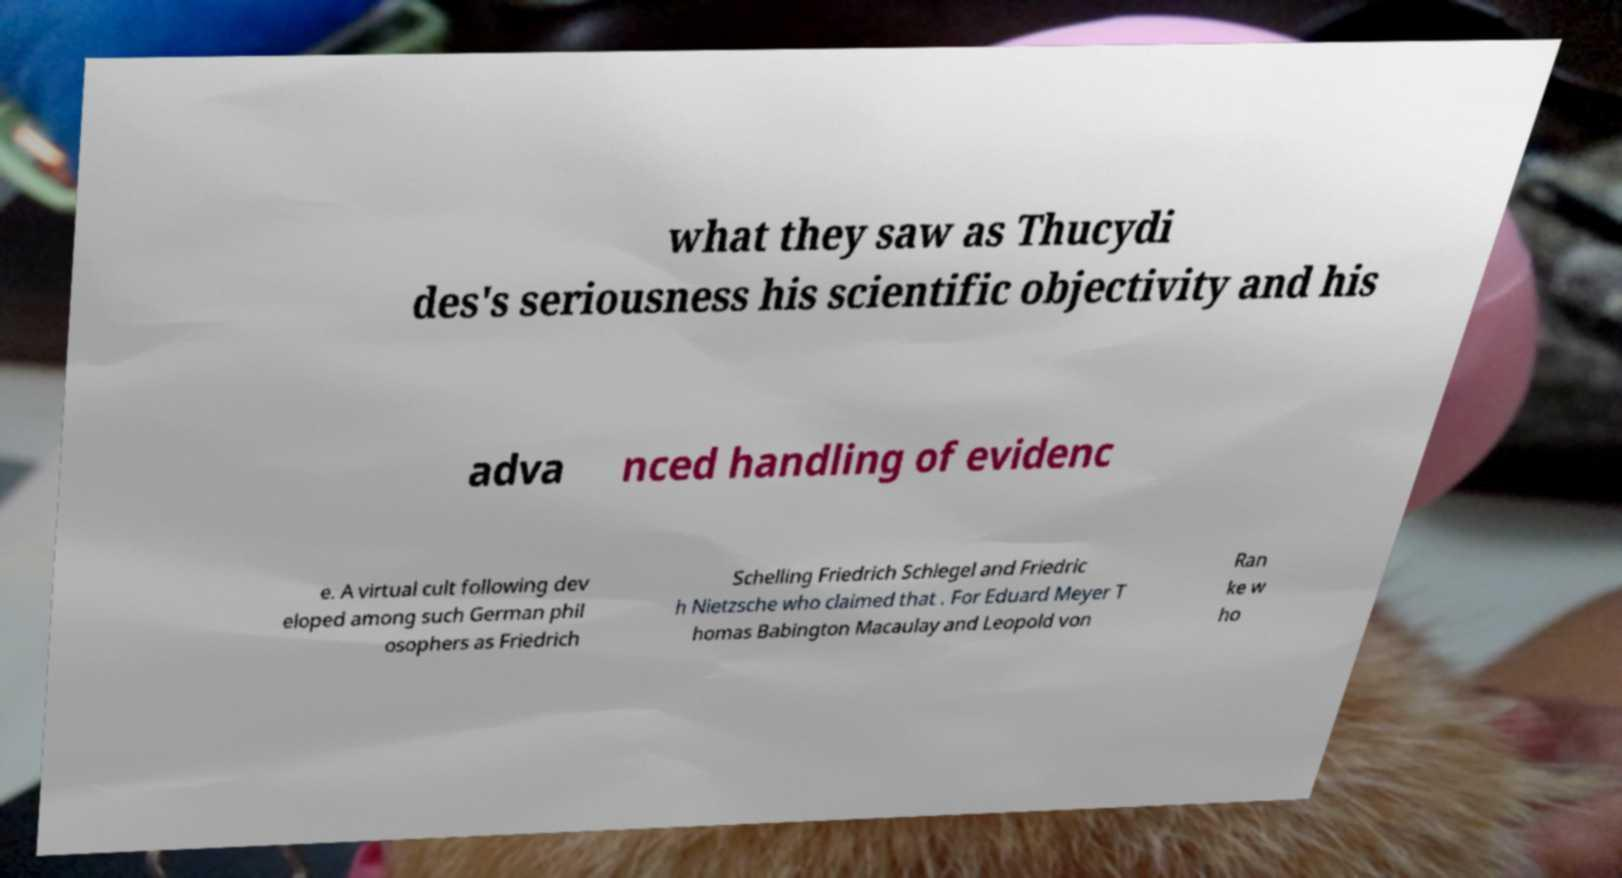Please read and relay the text visible in this image. What does it say? what they saw as Thucydi des's seriousness his scientific objectivity and his adva nced handling of evidenc e. A virtual cult following dev eloped among such German phil osophers as Friedrich Schelling Friedrich Schlegel and Friedric h Nietzsche who claimed that . For Eduard Meyer T homas Babington Macaulay and Leopold von Ran ke w ho 